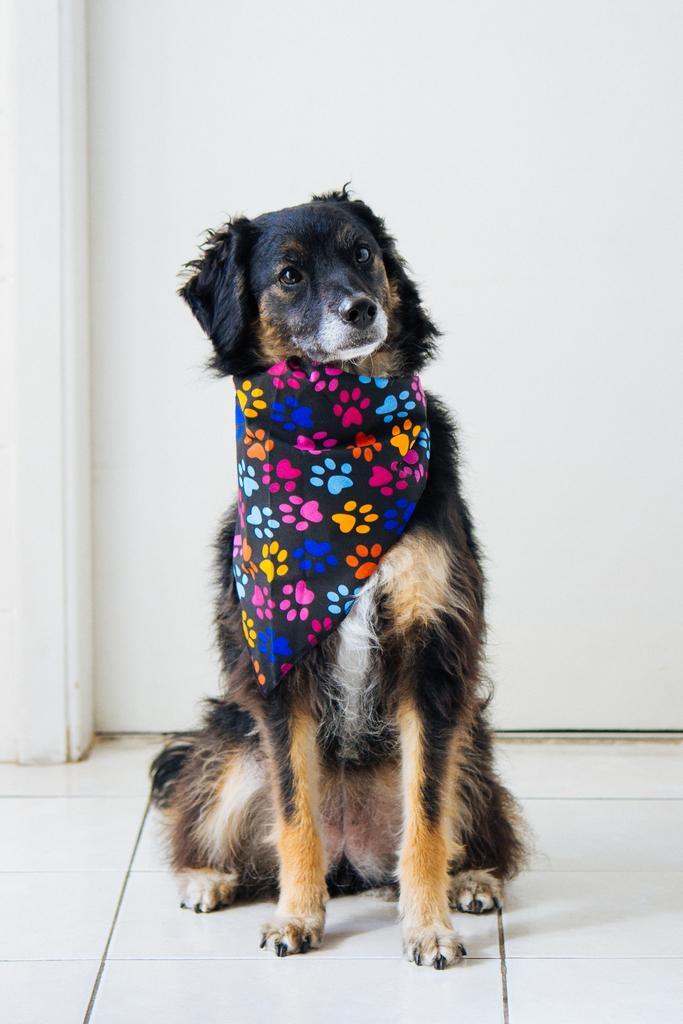Describe this image in one or two sentences. We can see a dog is sitting on the floor and there is a cloth tied to its neck and in the background we can see the door. 